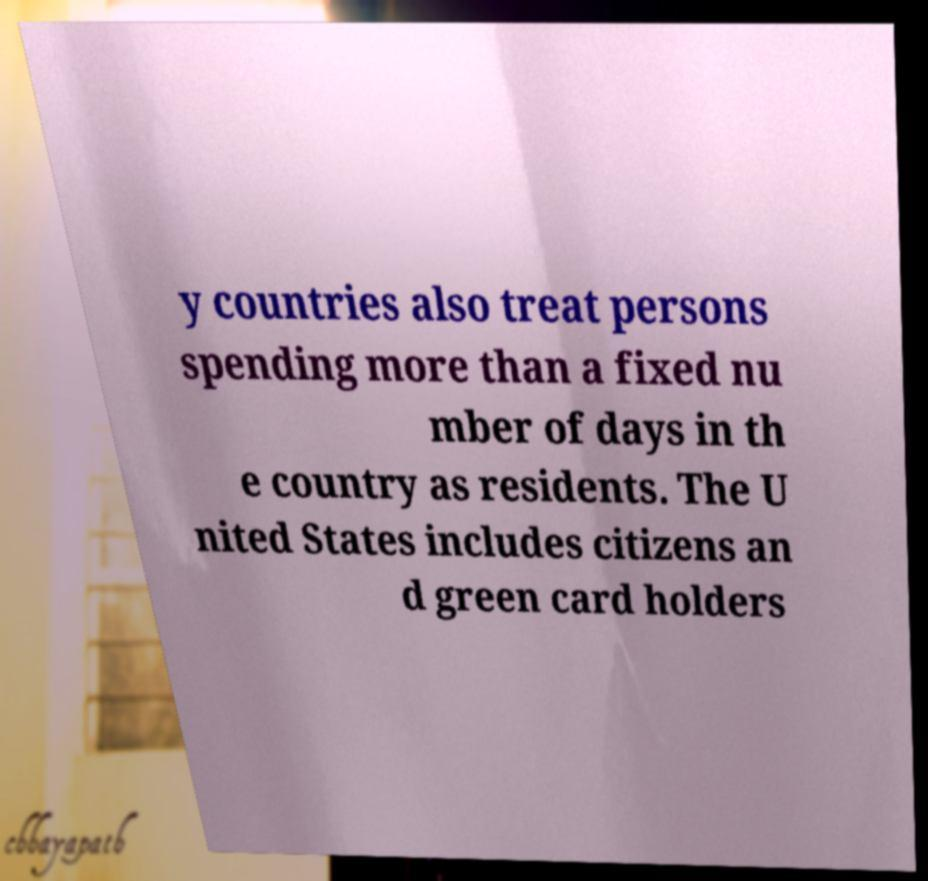Can you read and provide the text displayed in the image?This photo seems to have some interesting text. Can you extract and type it out for me? y countries also treat persons spending more than a fixed nu mber of days in th e country as residents. The U nited States includes citizens an d green card holders 